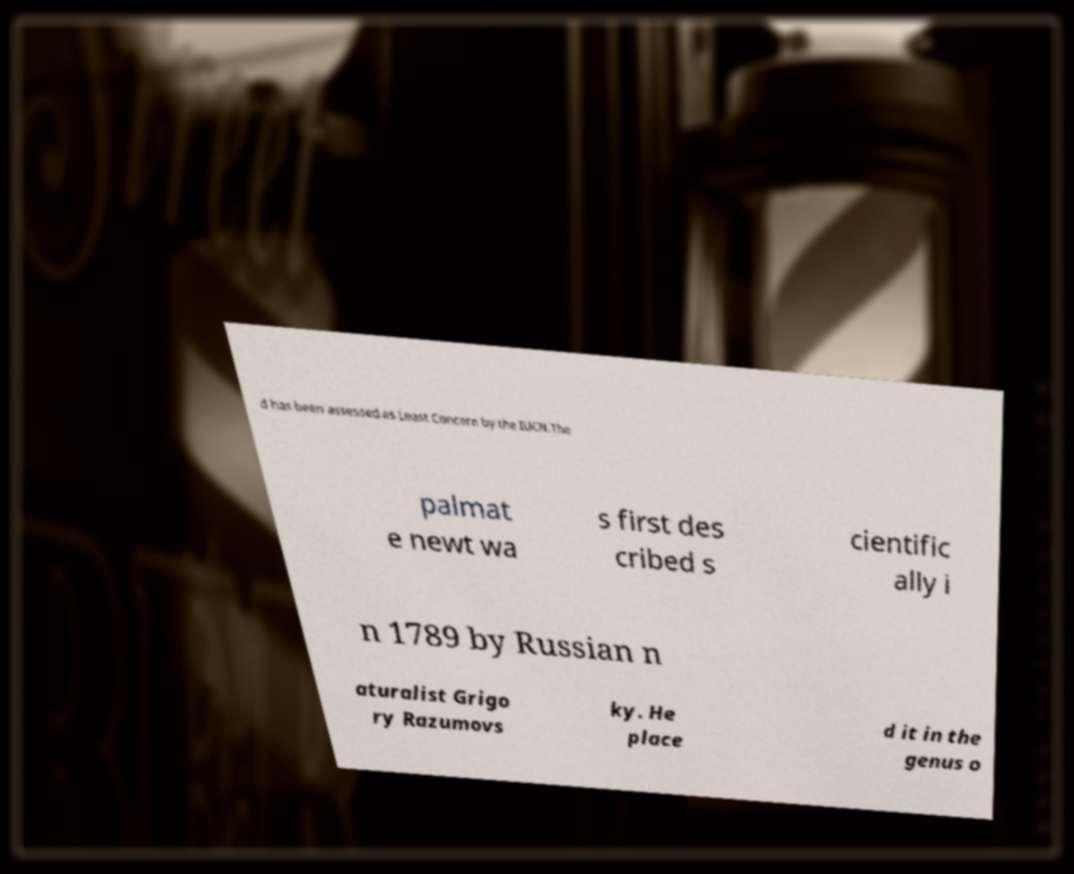What messages or text are displayed in this image? I need them in a readable, typed format. d has been assessed as Least Concern by the IUCN.The palmat e newt wa s first des cribed s cientific ally i n 1789 by Russian n aturalist Grigo ry Razumovs ky. He place d it in the genus o 